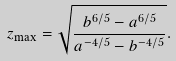Convert formula to latex. <formula><loc_0><loc_0><loc_500><loc_500>z _ { \max } = \sqrt { \frac { b ^ { 6 / 5 } - a ^ { 6 / 5 } } { a ^ { - 4 / 5 } - b ^ { - 4 / 5 } } } .</formula> 